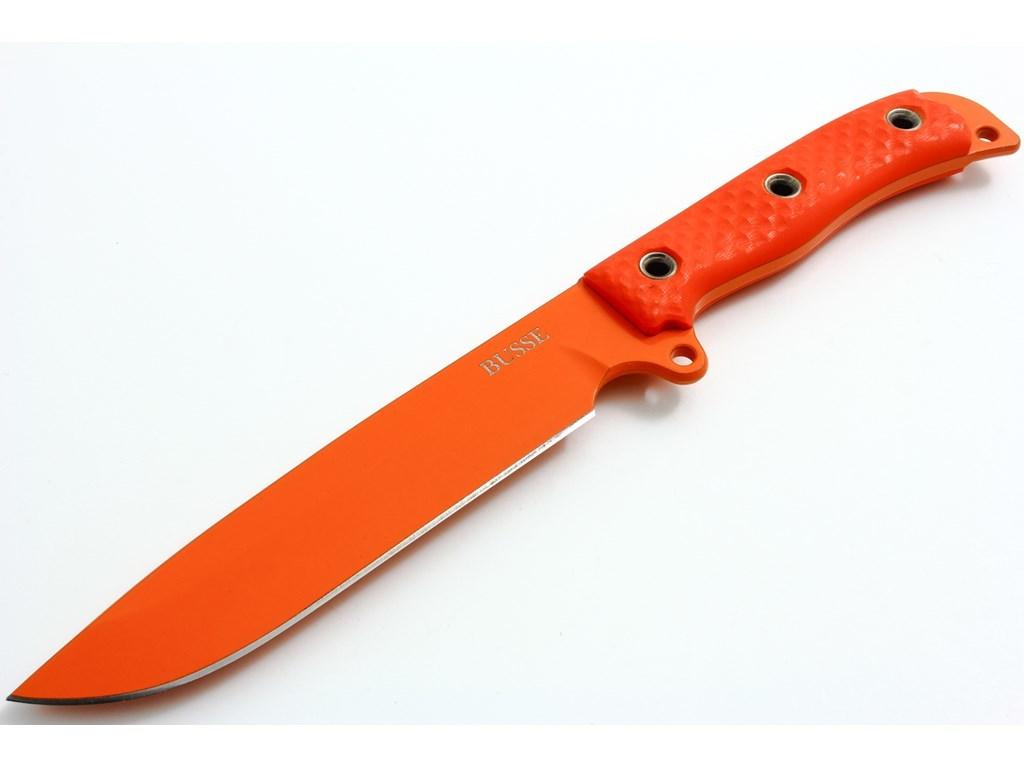What object can be seen in the image? There is a knife in the image. What is the color of the knife? The knife is in orange color. Are both the handle and the blade of the knife in the same color? Yes, both the handle and the blade of the knife are in orange color. What color is the background of the image? The background of the image is white in color. How many corks are floating in the water in the image? There are no corks or water present in the image; it features a knife with an orange handle and blade against a white background. 